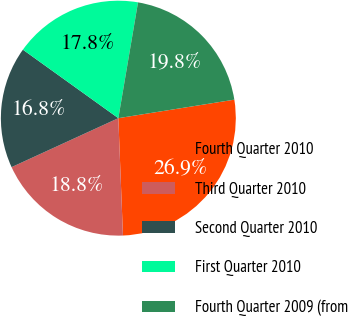<chart> <loc_0><loc_0><loc_500><loc_500><pie_chart><fcel>Fourth Quarter 2010<fcel>Third Quarter 2010<fcel>Second Quarter 2010<fcel>First Quarter 2010<fcel>Fourth Quarter 2009 (from<nl><fcel>26.89%<fcel>18.78%<fcel>16.75%<fcel>17.77%<fcel>19.8%<nl></chart> 